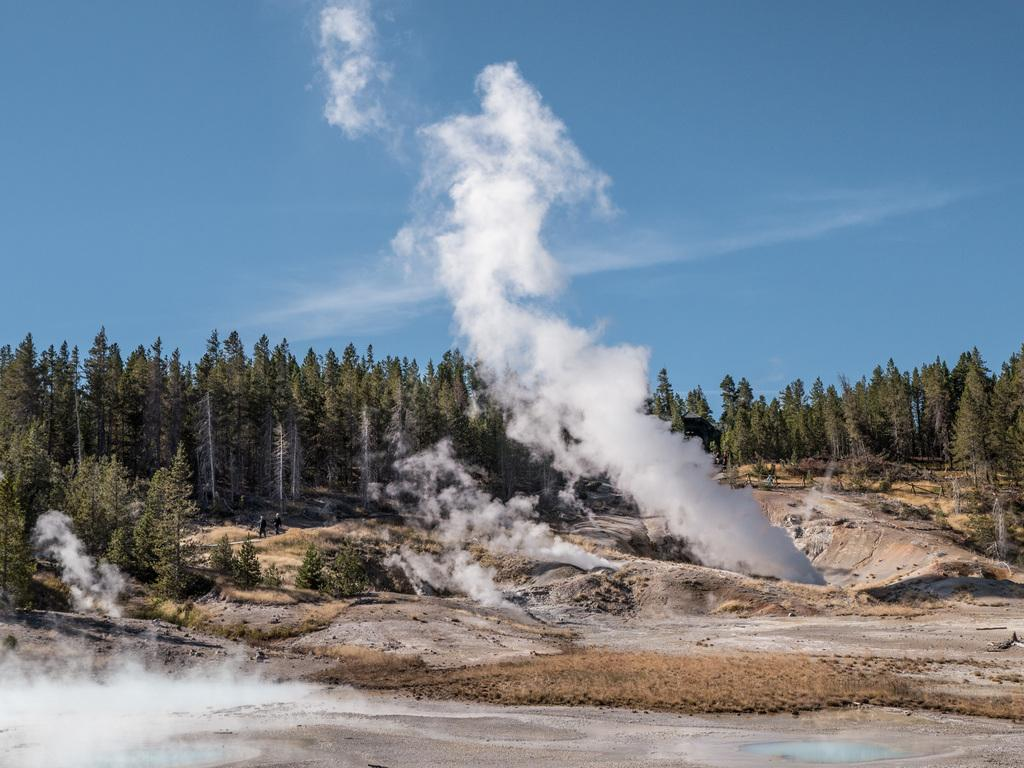What type of natural environment is depicted in the image? There are many trees in the image, suggesting a forest or wooded area. How many people are present in the image? There are two people in the image. What can be seen in the sky in the image? The sky is visible at the top of the image. What is the source of the smoke visible in the image? The source of the smoke is not specified in the image. What type of terrain is visible in the image? There is land visible in the image. Can you see any cables connecting the trees in the image? There are no cables connecting the trees visible in the image. Is the image depicting a rainstorm? The image does not depict a rainstorm; there is no indication of rain or stormy weather. 